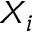Convert formula to latex. <formula><loc_0><loc_0><loc_500><loc_500>X _ { i }</formula> 